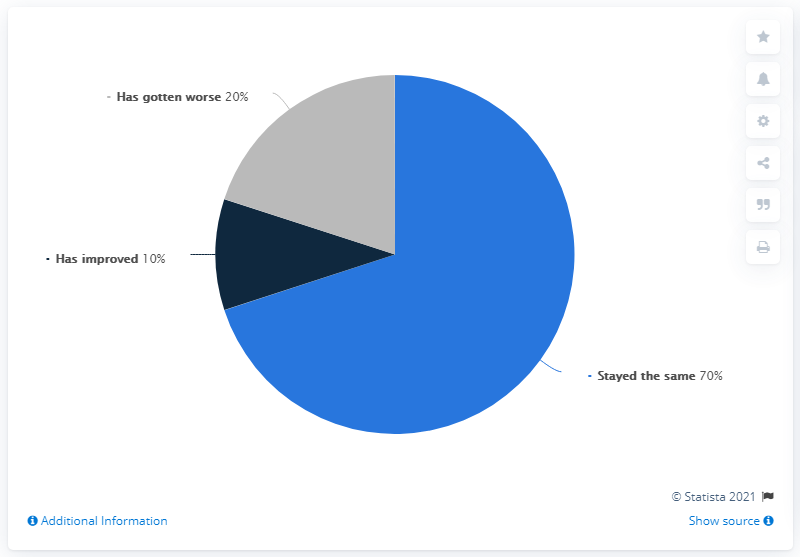Draw attention to some important aspects in this diagram. The mental health of Singaporeans during the COVID-19 circuit breaker period remained stable as of April 2020, with no significant change in overall well-being. According to the survey results, 20% of respondents reported that their mental health had deteriorated by April 2020. During the COVID-19 pandemic in Singapore, there was a period of time known as the "COVID-19 circuit breaker period" in which restrictions on social distancing and gatherings were temporarily lifted in an effort to boost the economy. According to data collected in April 2020, the highest state of mental health during this period was significantly higher than the lowest state. 